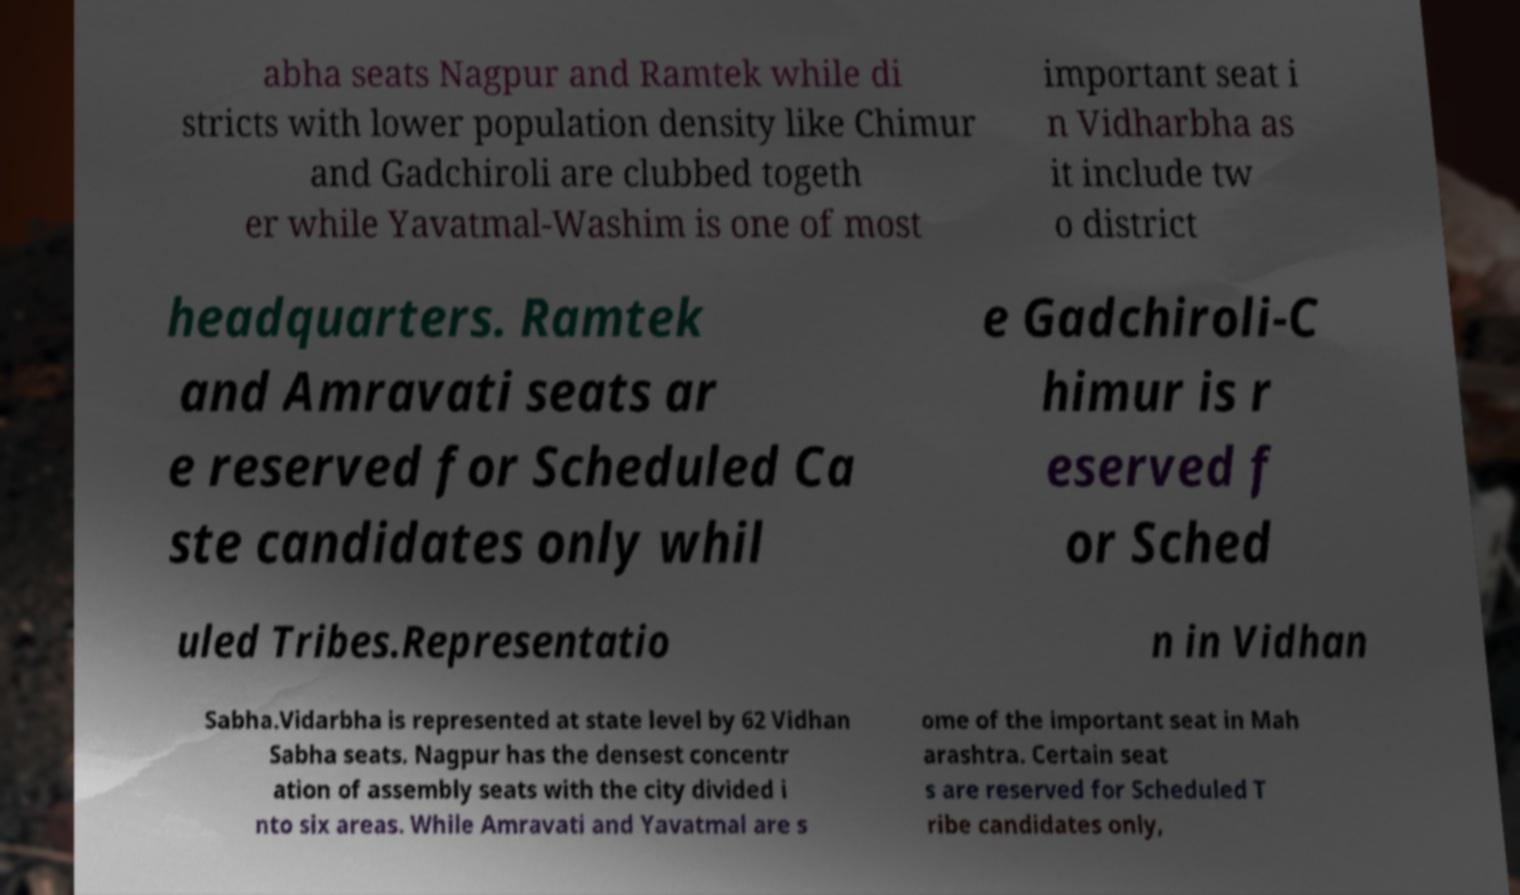Can you accurately transcribe the text from the provided image for me? abha seats Nagpur and Ramtek while di stricts with lower population density like Chimur and Gadchiroli are clubbed togeth er while Yavatmal-Washim is one of most important seat i n Vidharbha as it include tw o district headquarters. Ramtek and Amravati seats ar e reserved for Scheduled Ca ste candidates only whil e Gadchiroli-C himur is r eserved f or Sched uled Tribes.Representatio n in Vidhan Sabha.Vidarbha is represented at state level by 62 Vidhan Sabha seats. Nagpur has the densest concentr ation of assembly seats with the city divided i nto six areas. While Amravati and Yavatmal are s ome of the important seat in Mah arashtra. Certain seat s are reserved for Scheduled T ribe candidates only, 